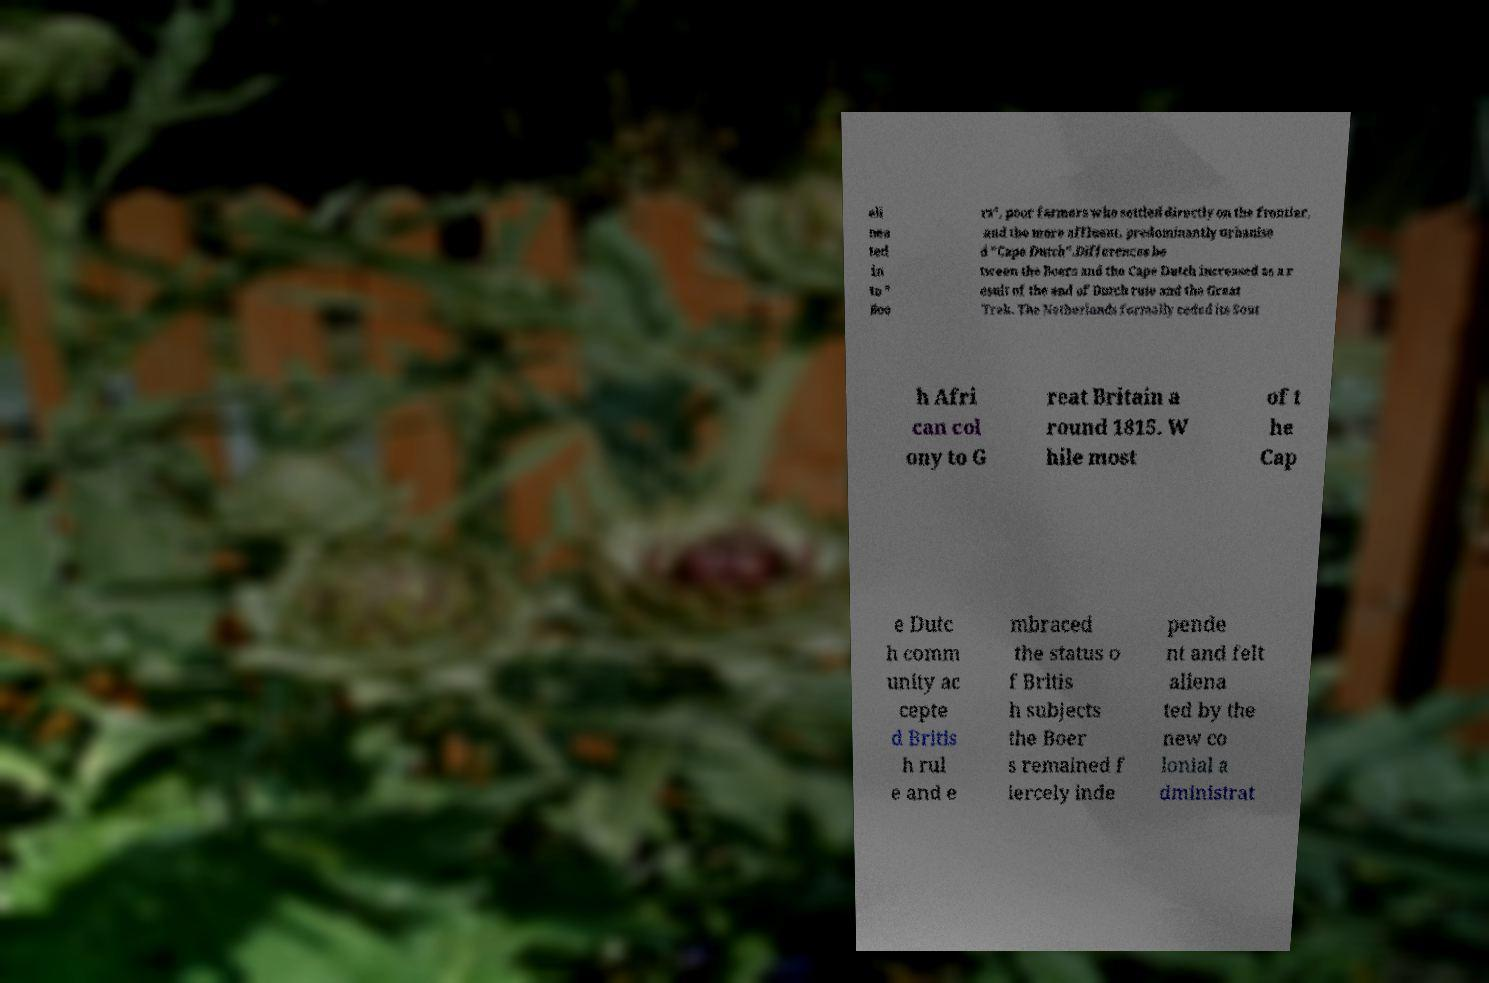For documentation purposes, I need the text within this image transcribed. Could you provide that? eli nea ted in to " Boe rs", poor farmers who settled directly on the frontier, and the more affluent, predominantly urbanise d "Cape Dutch".Differences be tween the Boers and the Cape Dutch increased as a r esult of the end of Dutch rule and the Great Trek. The Netherlands formally ceded its Sout h Afri can col ony to G reat Britain a round 1815. W hile most of t he Cap e Dutc h comm unity ac cepte d Britis h rul e and e mbraced the status o f Britis h subjects the Boer s remained f iercely inde pende nt and felt aliena ted by the new co lonial a dministrat 